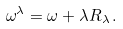Convert formula to latex. <formula><loc_0><loc_0><loc_500><loc_500>\omega ^ { \lambda } = \omega + \lambda R _ { \lambda } \, .</formula> 